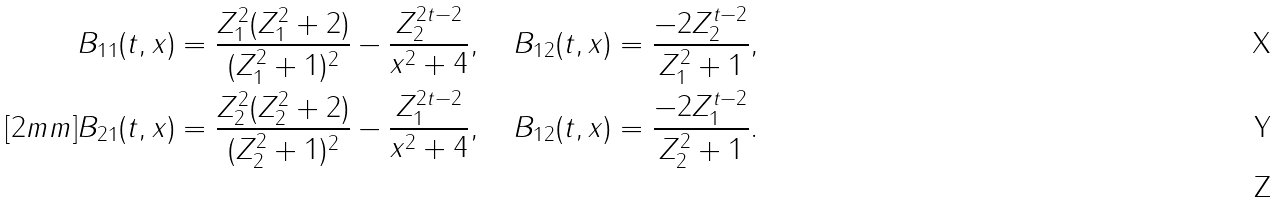Convert formula to latex. <formula><loc_0><loc_0><loc_500><loc_500>& B _ { 1 1 } ( t , x ) = \frac { Z _ { 1 } ^ { 2 } ( Z _ { 1 } ^ { 2 } + 2 ) } { ( Z _ { 1 } ^ { 2 } + 1 ) ^ { 2 } } - \frac { Z _ { 2 } ^ { 2 t - 2 } } { x ^ { 2 } + 4 } , \quad B _ { 1 2 } ( t , x ) = \frac { - 2 Z _ { 2 } ^ { t - 2 } } { Z _ { 1 } ^ { 2 } + 1 } , \\ [ 2 m m ] & B _ { 2 1 } ( t , x ) = \frac { Z _ { 2 } ^ { 2 } ( Z _ { 2 } ^ { 2 } + 2 ) } { ( Z _ { 2 } ^ { 2 } + 1 ) ^ { 2 } } - \frac { Z _ { 1 } ^ { 2 t - 2 } } { x ^ { 2 } + 4 } , \quad B _ { 1 2 } ( t , x ) = \frac { - 2 Z _ { 1 } ^ { t - 2 } } { Z _ { 2 } ^ { 2 } + 1 } . \\</formula> 